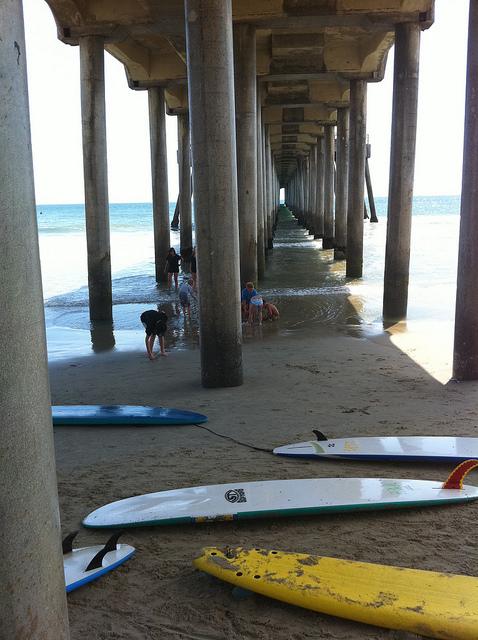Is this a bridge?
Give a very brief answer. No. Is this at the beach?
Quick response, please. Yes. What are the surfboards lying under?
Short answer required. Pier. 